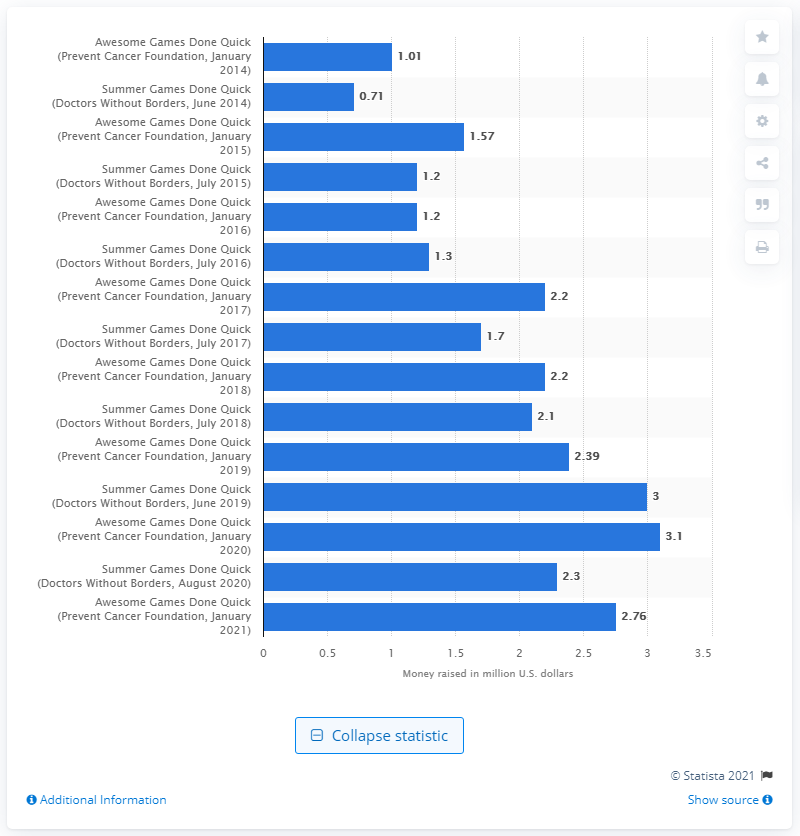Outline some significant characteristics in this image. The AGDQ raised a total of $2.76 million for Doctors Without Borders in its most recent event. 